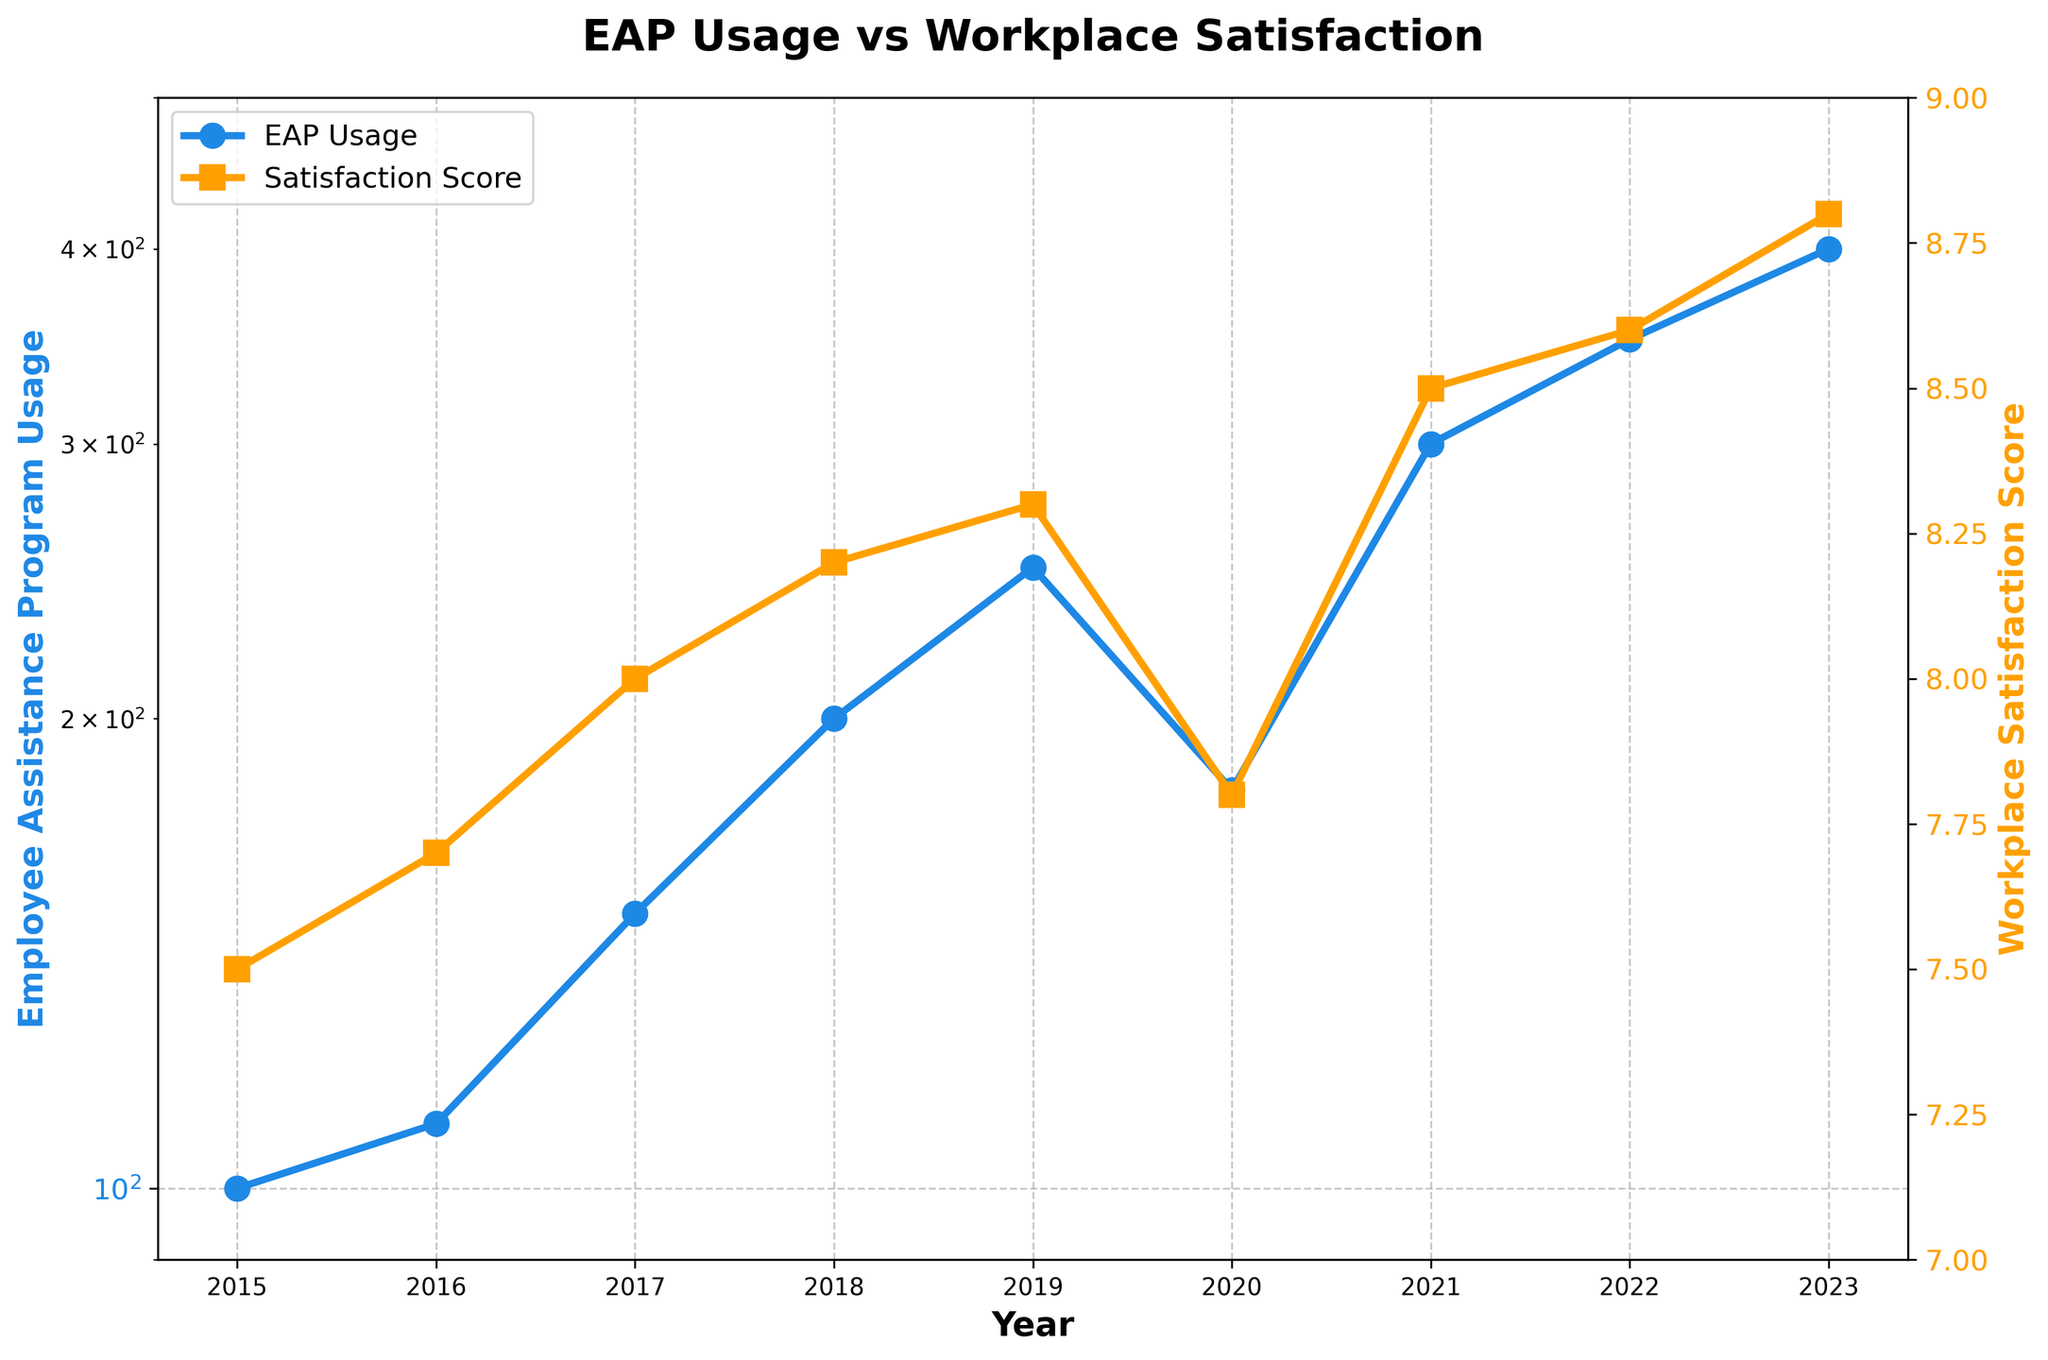What is the title of the plot? The title is the main text displayed at the top of the plot. Here, it provides the context for what the plot represents.
Answer: EAP Usage vs Workplace Satisfaction What are the colors used for the two lines in the plot? To identify the colors, look at the lines and their respective legends.
Answer: Blue and Orange What is the Employee Assistance Program Usage in 2023? Trace the blue line for EAP usage to the year 2023 on the x-axis.
Answer: 400 What is the overall trend in Employee Assistance Program Usage from 2015 to 2023? Observe the direction of the blue line from left to right between 2015 and 2023.
Answer: Increasing In which year did the Workplace Satisfaction Score drop significantly? Look for a noticeable dip in the orange line that represents workplace satisfaction scores.
Answer: 2020 How many times did Employee Assistance Program Usage increase by more than 50 units compared to the previous year? Determine the years where the vertical distance between consecutive points in the blue line represents an increase of more than 50 units.
Answer: Four times (2017, 2018, 2021, 2022) What’s the range of the Employee Assistance Program Usage values shown on the plot? Identify the minimum and maximum values for EAP usage from the blue line.
Answer: 100 to 400 How does the Workplace Satisfaction Score in 2023 compare to that in 2015? Compare the values of the orange line for the years 2015 and 2023.
Answer: Increased What is the relationship between the Employee Assistance Program Usage and Workplace Satisfaction Score in the years 2017 and 2018? Compare the changes in both blue and orange lines between these two years.
Answer: Both increased Based on the plotted data, what can you infer about the potential correlation between EAP Usage and Workplace Satisfaction? Observe how the trends of the two lines (blue for EAP Usage and orange for Satisfaction) move together typically.
Answer: Positive correlation 